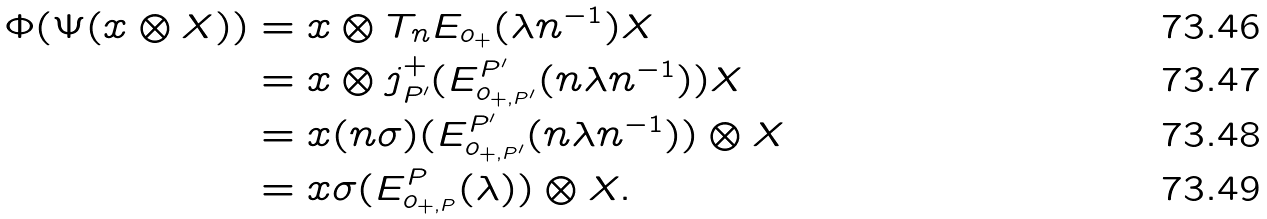Convert formula to latex. <formula><loc_0><loc_0><loc_500><loc_500>\Phi ( \Psi ( x \otimes X ) ) & = x \otimes T _ { n } E _ { o _ { + } } ( \lambda n ^ { - 1 } ) X \\ & = x \otimes j _ { P ^ { \prime } } ^ { + } ( E _ { o _ { + , P ^ { \prime } } } ^ { P ^ { \prime } } ( n \lambda n ^ { - 1 } ) ) X \\ & = x ( n \sigma ) ( E _ { o _ { + , P ^ { \prime } } } ^ { P ^ { \prime } } ( n \lambda n ^ { - 1 } ) ) \otimes X \\ & = x \sigma ( E ^ { P } _ { o _ { + , P } } ( \lambda ) ) \otimes X .</formula> 